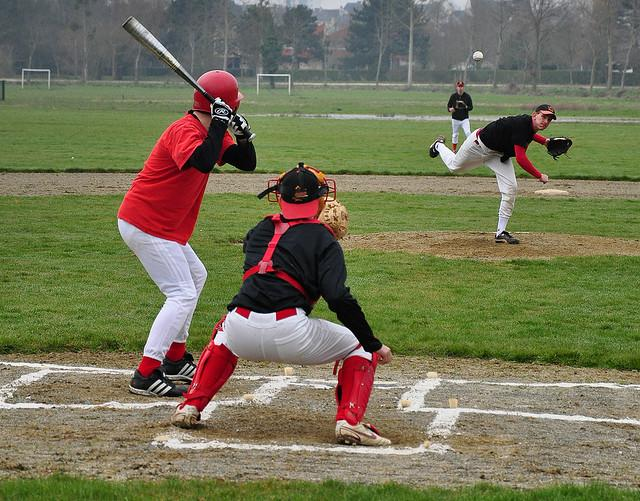What time of the year is it?

Choices:
A) spring
B) solstice
C) summer
D) winter winter 